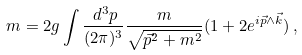Convert formula to latex. <formula><loc_0><loc_0><loc_500><loc_500>m = 2 g \int \frac { \, d ^ { 3 } p } { ( 2 \pi ) ^ { 3 } } \frac { m } { \sqrt { \vec { p } ^ { 2 } + m ^ { 2 } } } ( 1 + 2 e ^ { i \vec { p } \wedge \vec { k } } ) \, ,</formula> 